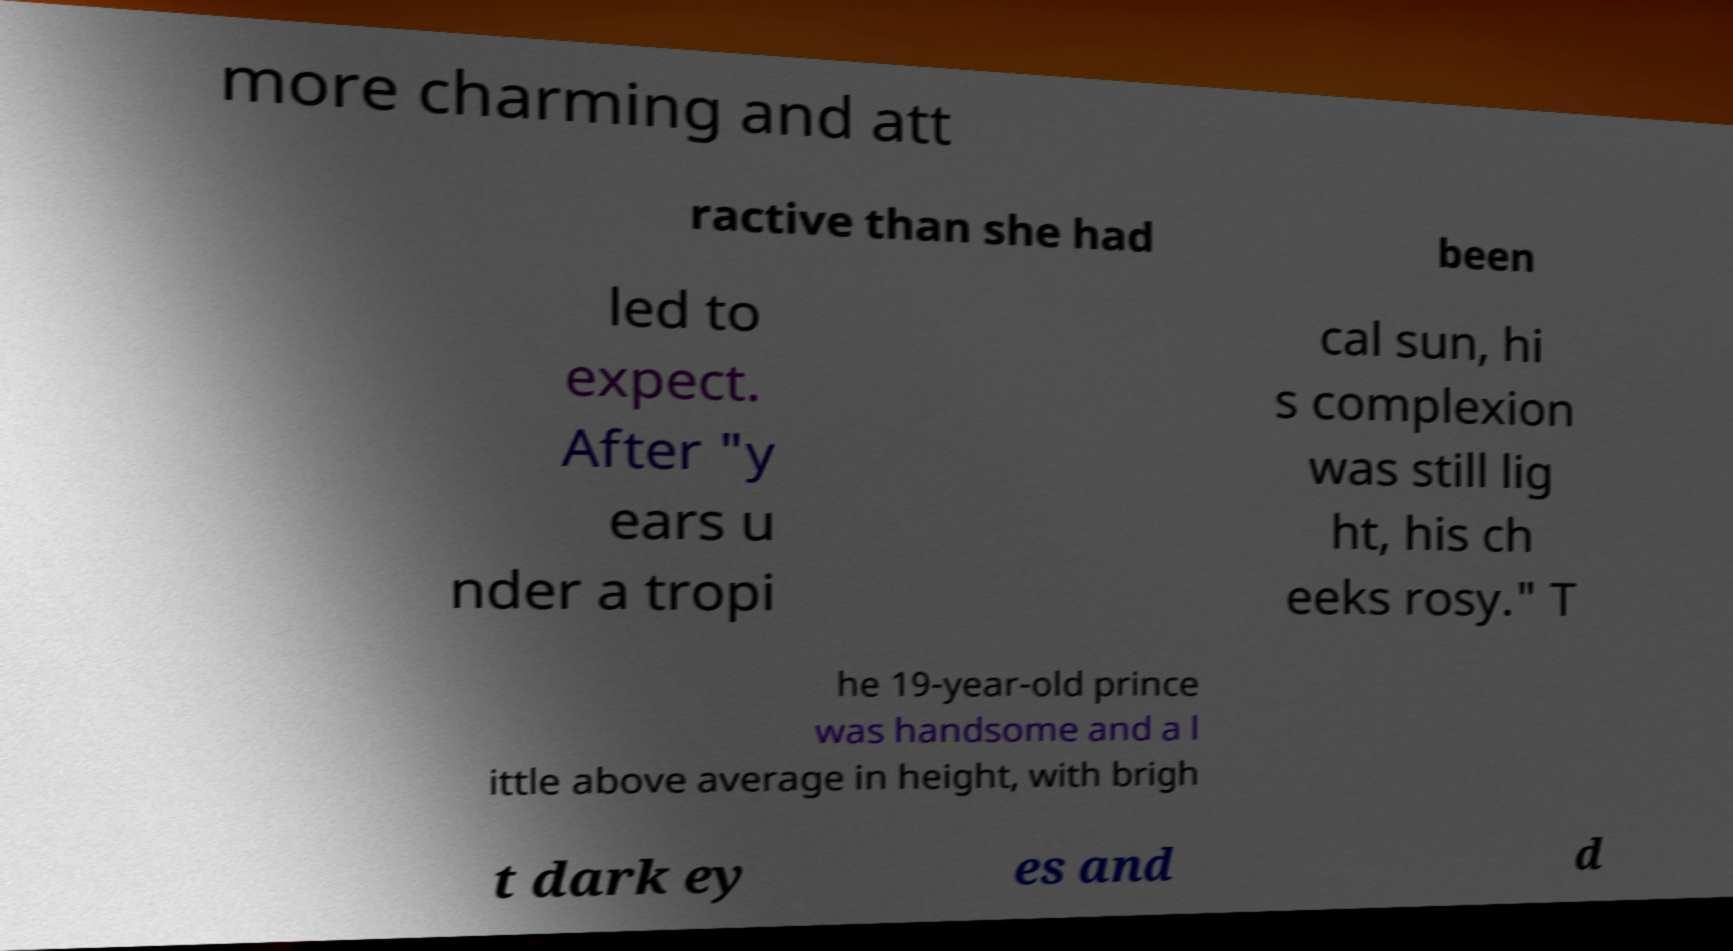Could you extract and type out the text from this image? more charming and att ractive than she had been led to expect. After "y ears u nder a tropi cal sun, hi s complexion was still lig ht, his ch eeks rosy." T he 19-year-old prince was handsome and a l ittle above average in height, with brigh t dark ey es and d 